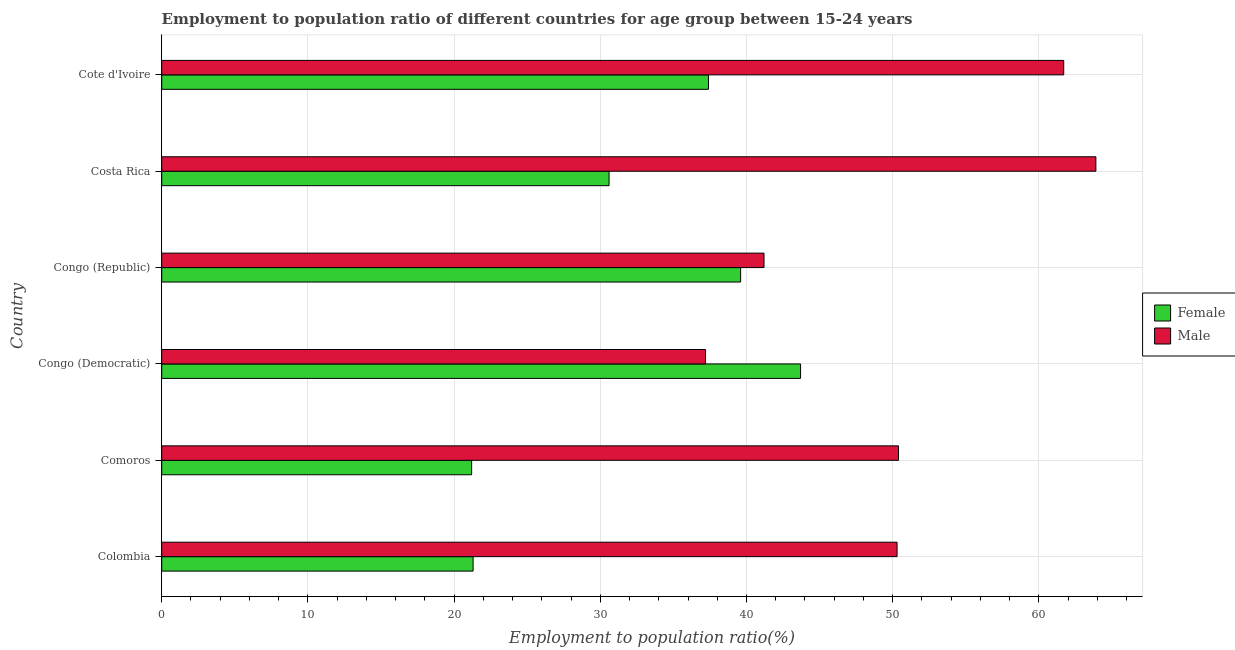What is the label of the 3rd group of bars from the top?
Provide a short and direct response. Congo (Republic). In how many cases, is the number of bars for a given country not equal to the number of legend labels?
Keep it short and to the point. 0. What is the employment to population ratio(male) in Comoros?
Offer a very short reply. 50.4. Across all countries, what is the maximum employment to population ratio(female)?
Make the answer very short. 43.7. Across all countries, what is the minimum employment to population ratio(female)?
Offer a terse response. 21.2. In which country was the employment to population ratio(male) minimum?
Your answer should be very brief. Congo (Democratic). What is the total employment to population ratio(female) in the graph?
Your answer should be compact. 193.8. What is the difference between the employment to population ratio(female) in Costa Rica and the employment to population ratio(male) in Congo (Republic)?
Provide a succinct answer. -10.6. What is the average employment to population ratio(female) per country?
Your answer should be very brief. 32.3. What is the difference between the employment to population ratio(male) and employment to population ratio(female) in Comoros?
Make the answer very short. 29.2. In how many countries, is the employment to population ratio(male) greater than 36 %?
Give a very brief answer. 6. What is the ratio of the employment to population ratio(male) in Comoros to that in Cote d'Ivoire?
Your response must be concise. 0.82. What is the difference between the highest and the lowest employment to population ratio(male)?
Provide a short and direct response. 26.7. In how many countries, is the employment to population ratio(female) greater than the average employment to population ratio(female) taken over all countries?
Offer a terse response. 3. What does the 1st bar from the bottom in Congo (Democratic) represents?
Ensure brevity in your answer.  Female. Are the values on the major ticks of X-axis written in scientific E-notation?
Provide a short and direct response. No. Does the graph contain any zero values?
Make the answer very short. No. Does the graph contain grids?
Provide a succinct answer. Yes. Where does the legend appear in the graph?
Offer a terse response. Center right. How many legend labels are there?
Make the answer very short. 2. How are the legend labels stacked?
Give a very brief answer. Vertical. What is the title of the graph?
Make the answer very short. Employment to population ratio of different countries for age group between 15-24 years. What is the label or title of the Y-axis?
Your response must be concise. Country. What is the Employment to population ratio(%) in Female in Colombia?
Keep it short and to the point. 21.3. What is the Employment to population ratio(%) in Male in Colombia?
Keep it short and to the point. 50.3. What is the Employment to population ratio(%) of Female in Comoros?
Offer a very short reply. 21.2. What is the Employment to population ratio(%) in Male in Comoros?
Keep it short and to the point. 50.4. What is the Employment to population ratio(%) in Female in Congo (Democratic)?
Make the answer very short. 43.7. What is the Employment to population ratio(%) of Male in Congo (Democratic)?
Your response must be concise. 37.2. What is the Employment to population ratio(%) of Female in Congo (Republic)?
Provide a short and direct response. 39.6. What is the Employment to population ratio(%) of Male in Congo (Republic)?
Keep it short and to the point. 41.2. What is the Employment to population ratio(%) in Female in Costa Rica?
Give a very brief answer. 30.6. What is the Employment to population ratio(%) of Male in Costa Rica?
Ensure brevity in your answer.  63.9. What is the Employment to population ratio(%) of Female in Cote d'Ivoire?
Provide a short and direct response. 37.4. What is the Employment to population ratio(%) of Male in Cote d'Ivoire?
Offer a terse response. 61.7. Across all countries, what is the maximum Employment to population ratio(%) in Female?
Offer a very short reply. 43.7. Across all countries, what is the maximum Employment to population ratio(%) of Male?
Offer a terse response. 63.9. Across all countries, what is the minimum Employment to population ratio(%) of Female?
Ensure brevity in your answer.  21.2. Across all countries, what is the minimum Employment to population ratio(%) of Male?
Offer a very short reply. 37.2. What is the total Employment to population ratio(%) in Female in the graph?
Offer a very short reply. 193.8. What is the total Employment to population ratio(%) of Male in the graph?
Your response must be concise. 304.7. What is the difference between the Employment to population ratio(%) in Female in Colombia and that in Comoros?
Offer a very short reply. 0.1. What is the difference between the Employment to population ratio(%) in Female in Colombia and that in Congo (Democratic)?
Your answer should be very brief. -22.4. What is the difference between the Employment to population ratio(%) in Female in Colombia and that in Congo (Republic)?
Make the answer very short. -18.3. What is the difference between the Employment to population ratio(%) of Female in Colombia and that in Cote d'Ivoire?
Offer a very short reply. -16.1. What is the difference between the Employment to population ratio(%) in Male in Colombia and that in Cote d'Ivoire?
Provide a short and direct response. -11.4. What is the difference between the Employment to population ratio(%) of Female in Comoros and that in Congo (Democratic)?
Your response must be concise. -22.5. What is the difference between the Employment to population ratio(%) of Female in Comoros and that in Congo (Republic)?
Offer a very short reply. -18.4. What is the difference between the Employment to population ratio(%) in Male in Comoros and that in Congo (Republic)?
Keep it short and to the point. 9.2. What is the difference between the Employment to population ratio(%) of Female in Comoros and that in Costa Rica?
Your answer should be very brief. -9.4. What is the difference between the Employment to population ratio(%) in Male in Comoros and that in Costa Rica?
Offer a very short reply. -13.5. What is the difference between the Employment to population ratio(%) of Female in Comoros and that in Cote d'Ivoire?
Give a very brief answer. -16.2. What is the difference between the Employment to population ratio(%) of Male in Congo (Democratic) and that in Congo (Republic)?
Give a very brief answer. -4. What is the difference between the Employment to population ratio(%) in Female in Congo (Democratic) and that in Costa Rica?
Ensure brevity in your answer.  13.1. What is the difference between the Employment to population ratio(%) of Male in Congo (Democratic) and that in Costa Rica?
Keep it short and to the point. -26.7. What is the difference between the Employment to population ratio(%) in Male in Congo (Democratic) and that in Cote d'Ivoire?
Ensure brevity in your answer.  -24.5. What is the difference between the Employment to population ratio(%) of Male in Congo (Republic) and that in Costa Rica?
Offer a very short reply. -22.7. What is the difference between the Employment to population ratio(%) of Male in Congo (Republic) and that in Cote d'Ivoire?
Your response must be concise. -20.5. What is the difference between the Employment to population ratio(%) of Female in Costa Rica and that in Cote d'Ivoire?
Ensure brevity in your answer.  -6.8. What is the difference between the Employment to population ratio(%) in Female in Colombia and the Employment to population ratio(%) in Male in Comoros?
Offer a terse response. -29.1. What is the difference between the Employment to population ratio(%) of Female in Colombia and the Employment to population ratio(%) of Male in Congo (Democratic)?
Give a very brief answer. -15.9. What is the difference between the Employment to population ratio(%) in Female in Colombia and the Employment to population ratio(%) in Male in Congo (Republic)?
Provide a short and direct response. -19.9. What is the difference between the Employment to population ratio(%) of Female in Colombia and the Employment to population ratio(%) of Male in Costa Rica?
Your answer should be compact. -42.6. What is the difference between the Employment to population ratio(%) of Female in Colombia and the Employment to population ratio(%) of Male in Cote d'Ivoire?
Your answer should be compact. -40.4. What is the difference between the Employment to population ratio(%) of Female in Comoros and the Employment to population ratio(%) of Male in Congo (Democratic)?
Offer a terse response. -16. What is the difference between the Employment to population ratio(%) of Female in Comoros and the Employment to population ratio(%) of Male in Costa Rica?
Provide a short and direct response. -42.7. What is the difference between the Employment to population ratio(%) in Female in Comoros and the Employment to population ratio(%) in Male in Cote d'Ivoire?
Offer a very short reply. -40.5. What is the difference between the Employment to population ratio(%) in Female in Congo (Democratic) and the Employment to population ratio(%) in Male in Costa Rica?
Offer a very short reply. -20.2. What is the difference between the Employment to population ratio(%) in Female in Congo (Democratic) and the Employment to population ratio(%) in Male in Cote d'Ivoire?
Provide a succinct answer. -18. What is the difference between the Employment to population ratio(%) of Female in Congo (Republic) and the Employment to population ratio(%) of Male in Costa Rica?
Give a very brief answer. -24.3. What is the difference between the Employment to population ratio(%) in Female in Congo (Republic) and the Employment to population ratio(%) in Male in Cote d'Ivoire?
Keep it short and to the point. -22.1. What is the difference between the Employment to population ratio(%) in Female in Costa Rica and the Employment to population ratio(%) in Male in Cote d'Ivoire?
Keep it short and to the point. -31.1. What is the average Employment to population ratio(%) of Female per country?
Your answer should be compact. 32.3. What is the average Employment to population ratio(%) of Male per country?
Keep it short and to the point. 50.78. What is the difference between the Employment to population ratio(%) of Female and Employment to population ratio(%) of Male in Colombia?
Provide a short and direct response. -29. What is the difference between the Employment to population ratio(%) of Female and Employment to population ratio(%) of Male in Comoros?
Provide a short and direct response. -29.2. What is the difference between the Employment to population ratio(%) of Female and Employment to population ratio(%) of Male in Congo (Democratic)?
Give a very brief answer. 6.5. What is the difference between the Employment to population ratio(%) in Female and Employment to population ratio(%) in Male in Costa Rica?
Your answer should be compact. -33.3. What is the difference between the Employment to population ratio(%) in Female and Employment to population ratio(%) in Male in Cote d'Ivoire?
Offer a very short reply. -24.3. What is the ratio of the Employment to population ratio(%) of Female in Colombia to that in Comoros?
Give a very brief answer. 1. What is the ratio of the Employment to population ratio(%) of Female in Colombia to that in Congo (Democratic)?
Offer a terse response. 0.49. What is the ratio of the Employment to population ratio(%) of Male in Colombia to that in Congo (Democratic)?
Your answer should be compact. 1.35. What is the ratio of the Employment to population ratio(%) of Female in Colombia to that in Congo (Republic)?
Give a very brief answer. 0.54. What is the ratio of the Employment to population ratio(%) of Male in Colombia to that in Congo (Republic)?
Provide a short and direct response. 1.22. What is the ratio of the Employment to population ratio(%) of Female in Colombia to that in Costa Rica?
Offer a very short reply. 0.7. What is the ratio of the Employment to population ratio(%) of Male in Colombia to that in Costa Rica?
Give a very brief answer. 0.79. What is the ratio of the Employment to population ratio(%) of Female in Colombia to that in Cote d'Ivoire?
Ensure brevity in your answer.  0.57. What is the ratio of the Employment to population ratio(%) in Male in Colombia to that in Cote d'Ivoire?
Offer a very short reply. 0.82. What is the ratio of the Employment to population ratio(%) of Female in Comoros to that in Congo (Democratic)?
Your answer should be very brief. 0.49. What is the ratio of the Employment to population ratio(%) in Male in Comoros to that in Congo (Democratic)?
Your answer should be compact. 1.35. What is the ratio of the Employment to population ratio(%) of Female in Comoros to that in Congo (Republic)?
Offer a terse response. 0.54. What is the ratio of the Employment to population ratio(%) of Male in Comoros to that in Congo (Republic)?
Offer a very short reply. 1.22. What is the ratio of the Employment to population ratio(%) of Female in Comoros to that in Costa Rica?
Make the answer very short. 0.69. What is the ratio of the Employment to population ratio(%) of Male in Comoros to that in Costa Rica?
Provide a succinct answer. 0.79. What is the ratio of the Employment to population ratio(%) in Female in Comoros to that in Cote d'Ivoire?
Ensure brevity in your answer.  0.57. What is the ratio of the Employment to population ratio(%) in Male in Comoros to that in Cote d'Ivoire?
Ensure brevity in your answer.  0.82. What is the ratio of the Employment to population ratio(%) of Female in Congo (Democratic) to that in Congo (Republic)?
Your response must be concise. 1.1. What is the ratio of the Employment to population ratio(%) in Male in Congo (Democratic) to that in Congo (Republic)?
Your answer should be compact. 0.9. What is the ratio of the Employment to population ratio(%) of Female in Congo (Democratic) to that in Costa Rica?
Provide a short and direct response. 1.43. What is the ratio of the Employment to population ratio(%) in Male in Congo (Democratic) to that in Costa Rica?
Your answer should be very brief. 0.58. What is the ratio of the Employment to population ratio(%) in Female in Congo (Democratic) to that in Cote d'Ivoire?
Provide a short and direct response. 1.17. What is the ratio of the Employment to population ratio(%) of Male in Congo (Democratic) to that in Cote d'Ivoire?
Make the answer very short. 0.6. What is the ratio of the Employment to population ratio(%) in Female in Congo (Republic) to that in Costa Rica?
Offer a very short reply. 1.29. What is the ratio of the Employment to population ratio(%) of Male in Congo (Republic) to that in Costa Rica?
Ensure brevity in your answer.  0.64. What is the ratio of the Employment to population ratio(%) of Female in Congo (Republic) to that in Cote d'Ivoire?
Offer a very short reply. 1.06. What is the ratio of the Employment to population ratio(%) of Male in Congo (Republic) to that in Cote d'Ivoire?
Your response must be concise. 0.67. What is the ratio of the Employment to population ratio(%) of Female in Costa Rica to that in Cote d'Ivoire?
Provide a short and direct response. 0.82. What is the ratio of the Employment to population ratio(%) in Male in Costa Rica to that in Cote d'Ivoire?
Make the answer very short. 1.04. What is the difference between the highest and the lowest Employment to population ratio(%) in Female?
Your response must be concise. 22.5. What is the difference between the highest and the lowest Employment to population ratio(%) of Male?
Offer a terse response. 26.7. 